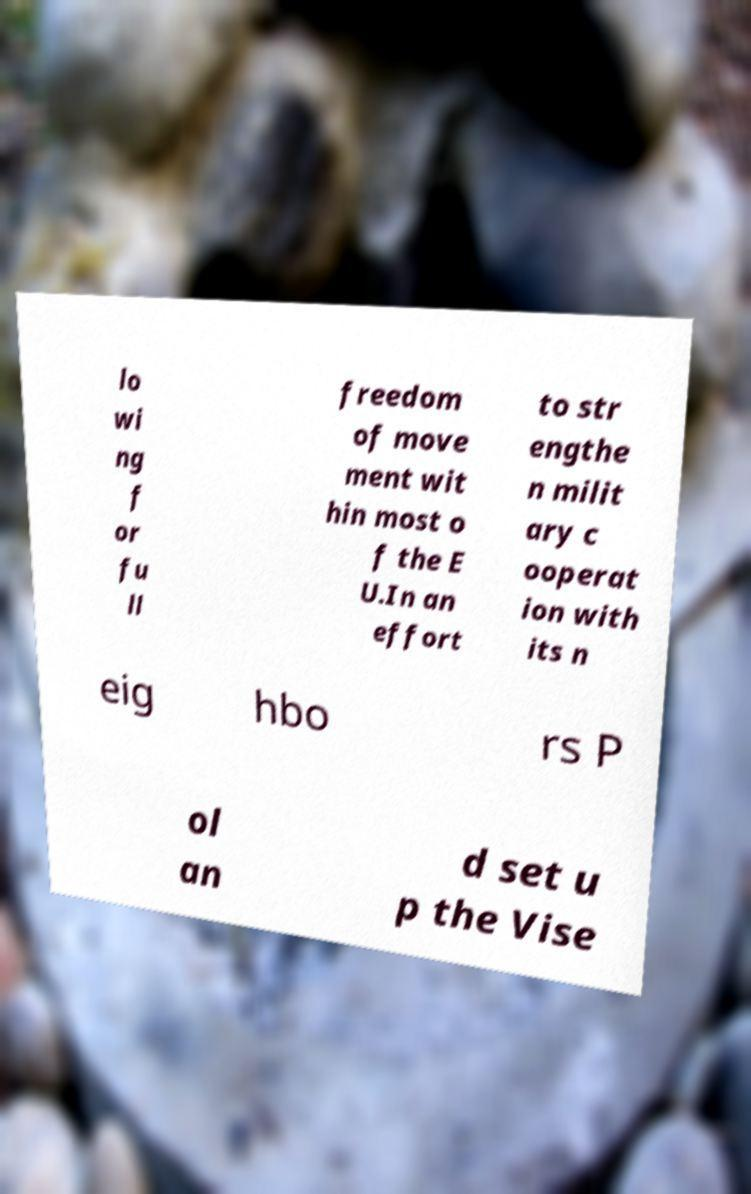Can you accurately transcribe the text from the provided image for me? lo wi ng f or fu ll freedom of move ment wit hin most o f the E U.In an effort to str engthe n milit ary c ooperat ion with its n eig hbo rs P ol an d set u p the Vise 